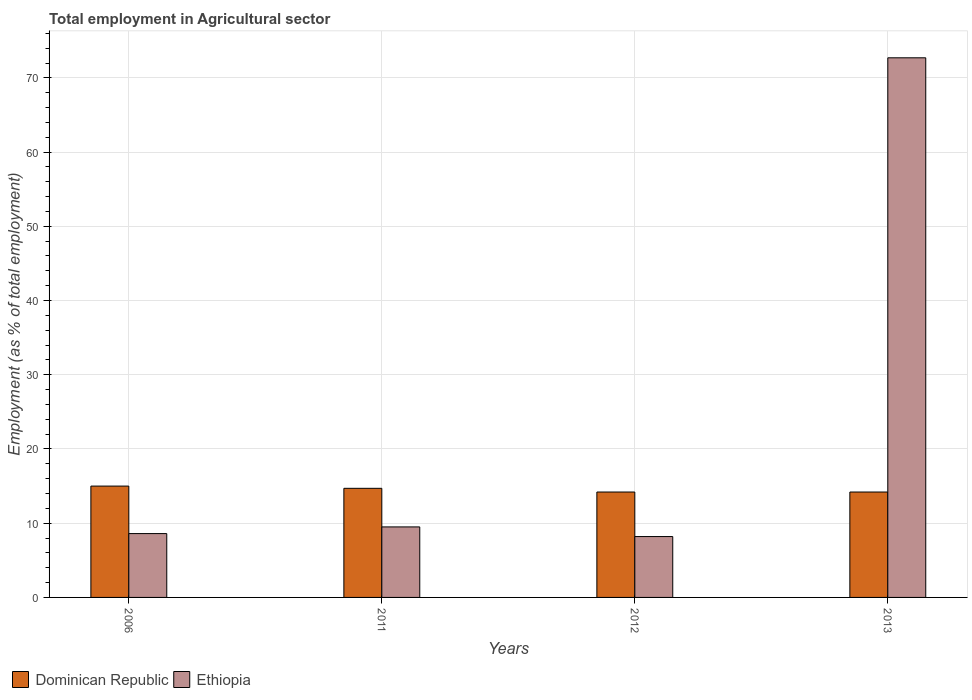How many different coloured bars are there?
Your answer should be compact. 2. How many groups of bars are there?
Make the answer very short. 4. Are the number of bars on each tick of the X-axis equal?
Keep it short and to the point. Yes. How many bars are there on the 3rd tick from the left?
Your answer should be very brief. 2. How many bars are there on the 4th tick from the right?
Keep it short and to the point. 2. What is the label of the 4th group of bars from the left?
Offer a terse response. 2013. What is the employment in agricultural sector in Dominican Republic in 2013?
Your answer should be very brief. 14.2. Across all years, what is the maximum employment in agricultural sector in Ethiopia?
Your response must be concise. 72.7. Across all years, what is the minimum employment in agricultural sector in Dominican Republic?
Keep it short and to the point. 14.2. In which year was the employment in agricultural sector in Ethiopia minimum?
Give a very brief answer. 2012. What is the total employment in agricultural sector in Ethiopia in the graph?
Provide a succinct answer. 99. What is the difference between the employment in agricultural sector in Ethiopia in 2011 and that in 2012?
Provide a short and direct response. 1.3. What is the difference between the employment in agricultural sector in Dominican Republic in 2012 and the employment in agricultural sector in Ethiopia in 2013?
Your response must be concise. -58.5. What is the average employment in agricultural sector in Dominican Republic per year?
Give a very brief answer. 14.52. In the year 2012, what is the difference between the employment in agricultural sector in Ethiopia and employment in agricultural sector in Dominican Republic?
Offer a terse response. -6. In how many years, is the employment in agricultural sector in Dominican Republic greater than 30 %?
Provide a short and direct response. 0. What is the ratio of the employment in agricultural sector in Ethiopia in 2012 to that in 2013?
Your response must be concise. 0.11. Is the employment in agricultural sector in Dominican Republic in 2011 less than that in 2013?
Give a very brief answer. No. What is the difference between the highest and the second highest employment in agricultural sector in Dominican Republic?
Your answer should be compact. 0.3. What is the difference between the highest and the lowest employment in agricultural sector in Ethiopia?
Your answer should be very brief. 64.5. In how many years, is the employment in agricultural sector in Ethiopia greater than the average employment in agricultural sector in Ethiopia taken over all years?
Offer a terse response. 1. Is the sum of the employment in agricultural sector in Ethiopia in 2006 and 2012 greater than the maximum employment in agricultural sector in Dominican Republic across all years?
Your response must be concise. Yes. What does the 1st bar from the left in 2011 represents?
Provide a short and direct response. Dominican Republic. What does the 2nd bar from the right in 2006 represents?
Your response must be concise. Dominican Republic. Are all the bars in the graph horizontal?
Your response must be concise. No. Are the values on the major ticks of Y-axis written in scientific E-notation?
Ensure brevity in your answer.  No. Does the graph contain any zero values?
Give a very brief answer. No. Does the graph contain grids?
Offer a terse response. Yes. Where does the legend appear in the graph?
Offer a very short reply. Bottom left. How many legend labels are there?
Make the answer very short. 2. How are the legend labels stacked?
Offer a very short reply. Horizontal. What is the title of the graph?
Your response must be concise. Total employment in Agricultural sector. Does "Senegal" appear as one of the legend labels in the graph?
Your answer should be very brief. No. What is the label or title of the Y-axis?
Make the answer very short. Employment (as % of total employment). What is the Employment (as % of total employment) in Ethiopia in 2006?
Keep it short and to the point. 8.6. What is the Employment (as % of total employment) of Dominican Republic in 2011?
Provide a short and direct response. 14.7. What is the Employment (as % of total employment) in Ethiopia in 2011?
Offer a terse response. 9.5. What is the Employment (as % of total employment) in Dominican Republic in 2012?
Provide a short and direct response. 14.2. What is the Employment (as % of total employment) of Ethiopia in 2012?
Provide a succinct answer. 8.2. What is the Employment (as % of total employment) of Dominican Republic in 2013?
Your answer should be very brief. 14.2. What is the Employment (as % of total employment) of Ethiopia in 2013?
Keep it short and to the point. 72.7. Across all years, what is the maximum Employment (as % of total employment) in Ethiopia?
Offer a terse response. 72.7. Across all years, what is the minimum Employment (as % of total employment) in Dominican Republic?
Provide a succinct answer. 14.2. Across all years, what is the minimum Employment (as % of total employment) in Ethiopia?
Your answer should be compact. 8.2. What is the total Employment (as % of total employment) in Dominican Republic in the graph?
Keep it short and to the point. 58.1. What is the difference between the Employment (as % of total employment) in Dominican Republic in 2006 and that in 2011?
Make the answer very short. 0.3. What is the difference between the Employment (as % of total employment) in Ethiopia in 2006 and that in 2011?
Give a very brief answer. -0.9. What is the difference between the Employment (as % of total employment) of Dominican Republic in 2006 and that in 2012?
Ensure brevity in your answer.  0.8. What is the difference between the Employment (as % of total employment) in Dominican Republic in 2006 and that in 2013?
Provide a short and direct response. 0.8. What is the difference between the Employment (as % of total employment) in Ethiopia in 2006 and that in 2013?
Ensure brevity in your answer.  -64.1. What is the difference between the Employment (as % of total employment) in Dominican Republic in 2011 and that in 2013?
Ensure brevity in your answer.  0.5. What is the difference between the Employment (as % of total employment) of Ethiopia in 2011 and that in 2013?
Give a very brief answer. -63.2. What is the difference between the Employment (as % of total employment) of Dominican Republic in 2012 and that in 2013?
Your answer should be compact. 0. What is the difference between the Employment (as % of total employment) in Ethiopia in 2012 and that in 2013?
Provide a short and direct response. -64.5. What is the difference between the Employment (as % of total employment) in Dominican Republic in 2006 and the Employment (as % of total employment) in Ethiopia in 2013?
Make the answer very short. -57.7. What is the difference between the Employment (as % of total employment) of Dominican Republic in 2011 and the Employment (as % of total employment) of Ethiopia in 2012?
Make the answer very short. 6.5. What is the difference between the Employment (as % of total employment) of Dominican Republic in 2011 and the Employment (as % of total employment) of Ethiopia in 2013?
Keep it short and to the point. -58. What is the difference between the Employment (as % of total employment) in Dominican Republic in 2012 and the Employment (as % of total employment) in Ethiopia in 2013?
Give a very brief answer. -58.5. What is the average Employment (as % of total employment) in Dominican Republic per year?
Your answer should be very brief. 14.53. What is the average Employment (as % of total employment) of Ethiopia per year?
Offer a terse response. 24.75. In the year 2013, what is the difference between the Employment (as % of total employment) in Dominican Republic and Employment (as % of total employment) in Ethiopia?
Provide a short and direct response. -58.5. What is the ratio of the Employment (as % of total employment) in Dominican Republic in 2006 to that in 2011?
Make the answer very short. 1.02. What is the ratio of the Employment (as % of total employment) in Ethiopia in 2006 to that in 2011?
Offer a terse response. 0.91. What is the ratio of the Employment (as % of total employment) of Dominican Republic in 2006 to that in 2012?
Give a very brief answer. 1.06. What is the ratio of the Employment (as % of total employment) in Ethiopia in 2006 to that in 2012?
Your answer should be compact. 1.05. What is the ratio of the Employment (as % of total employment) of Dominican Republic in 2006 to that in 2013?
Offer a very short reply. 1.06. What is the ratio of the Employment (as % of total employment) of Ethiopia in 2006 to that in 2013?
Give a very brief answer. 0.12. What is the ratio of the Employment (as % of total employment) in Dominican Republic in 2011 to that in 2012?
Keep it short and to the point. 1.04. What is the ratio of the Employment (as % of total employment) of Ethiopia in 2011 to that in 2012?
Offer a terse response. 1.16. What is the ratio of the Employment (as % of total employment) of Dominican Republic in 2011 to that in 2013?
Make the answer very short. 1.04. What is the ratio of the Employment (as % of total employment) in Ethiopia in 2011 to that in 2013?
Offer a very short reply. 0.13. What is the ratio of the Employment (as % of total employment) of Ethiopia in 2012 to that in 2013?
Your answer should be very brief. 0.11. What is the difference between the highest and the second highest Employment (as % of total employment) in Ethiopia?
Your answer should be compact. 63.2. What is the difference between the highest and the lowest Employment (as % of total employment) in Ethiopia?
Your response must be concise. 64.5. 